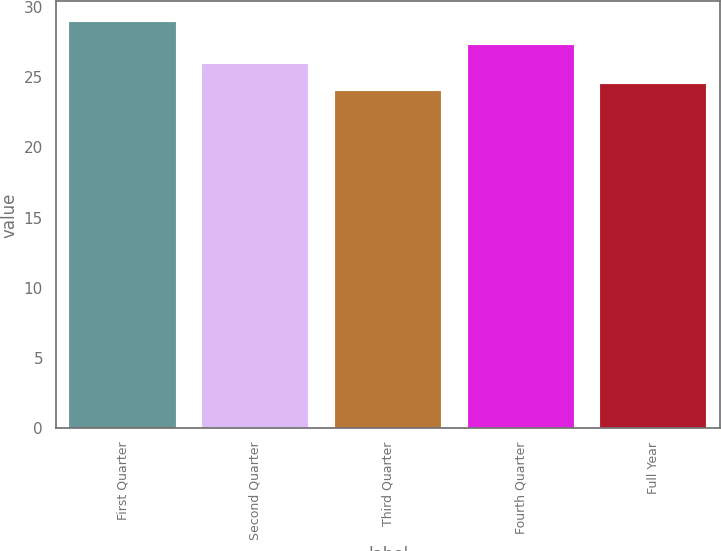Convert chart to OTSL. <chart><loc_0><loc_0><loc_500><loc_500><bar_chart><fcel>First Quarter<fcel>Second Quarter<fcel>Third Quarter<fcel>Fourth Quarter<fcel>Full Year<nl><fcel>28.94<fcel>25.9<fcel>24<fcel>27.27<fcel>24.49<nl></chart> 